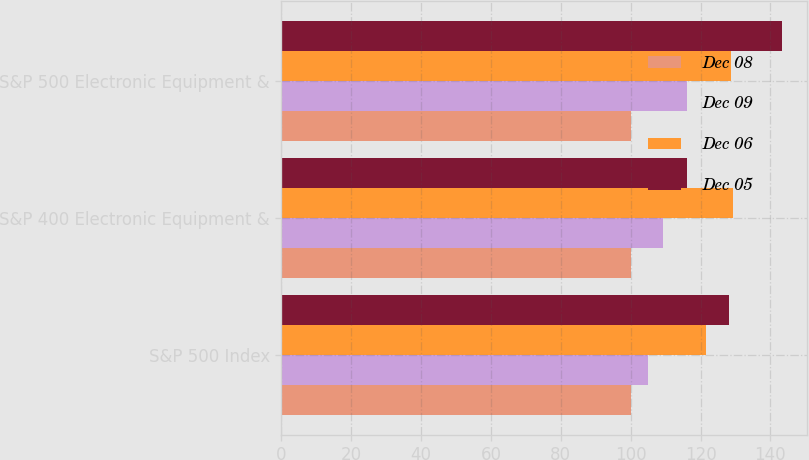Convert chart. <chart><loc_0><loc_0><loc_500><loc_500><stacked_bar_chart><ecel><fcel>S&P 500 Index<fcel>S&P 400 Electronic Equipment &<fcel>S&P 500 Electronic Equipment &<nl><fcel>Dec 08<fcel>100<fcel>100<fcel>100<nl><fcel>Dec 09<fcel>104.91<fcel>109.24<fcel>116.03<nl><fcel>Dec 06<fcel>121.48<fcel>129.2<fcel>128.75<nl><fcel>Dec 05<fcel>128.16<fcel>116.03<fcel>143.38<nl></chart> 